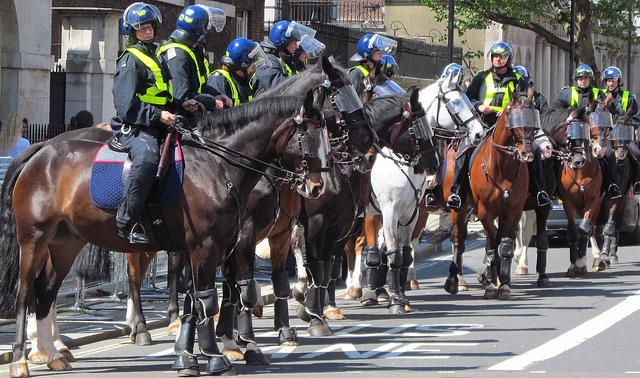Why do the horses wear leg coverings?

Choices:
A) parade elevation
B) armor
C) decoration
D) digging tools armor 